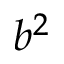<formula> <loc_0><loc_0><loc_500><loc_500>b ^ { 2 }</formula> 